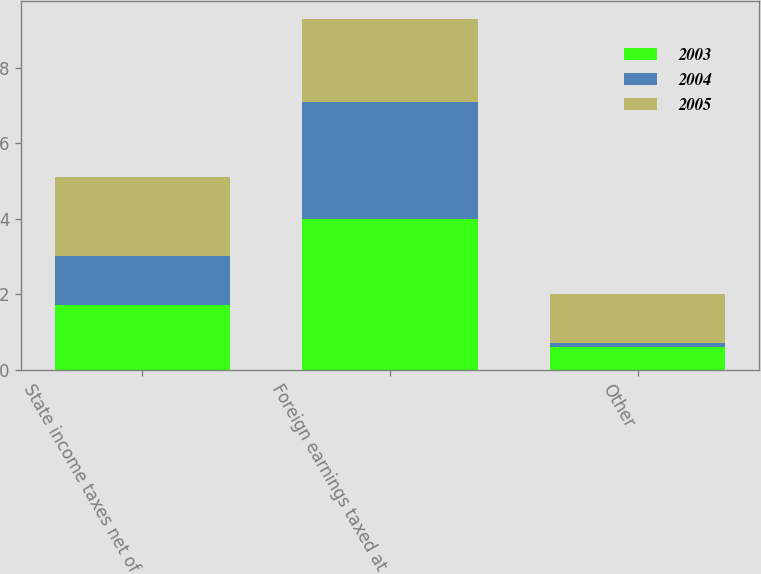Convert chart. <chart><loc_0><loc_0><loc_500><loc_500><stacked_bar_chart><ecel><fcel>State income taxes net of<fcel>Foreign earnings taxed at<fcel>Other<nl><fcel>2003<fcel>1.7<fcel>4<fcel>0.6<nl><fcel>2004<fcel>1.3<fcel>3.1<fcel>0.1<nl><fcel>2005<fcel>2.1<fcel>2.2<fcel>1.3<nl></chart> 